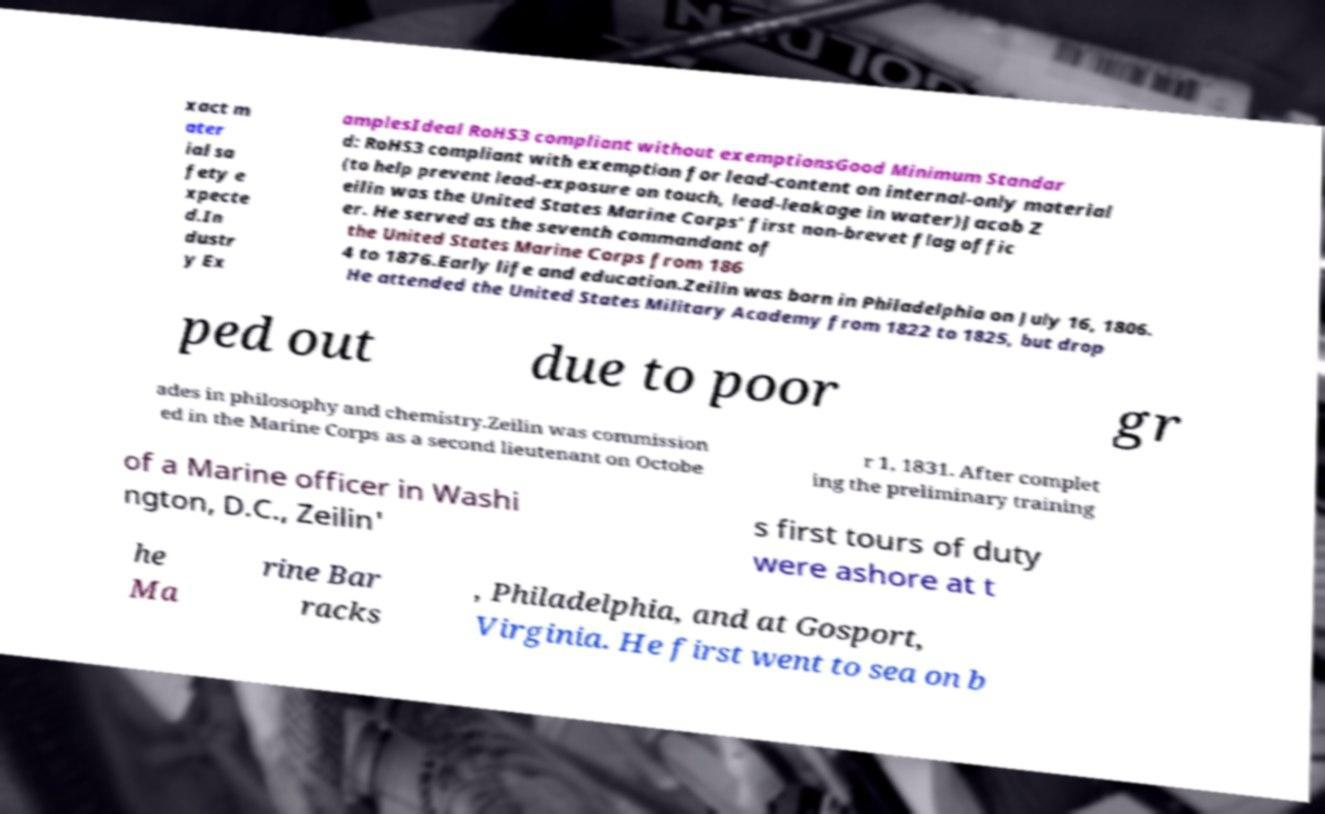There's text embedded in this image that I need extracted. Can you transcribe it verbatim? xact m ater ial sa fety e xpecte d.In dustr y Ex amplesIdeal RoHS3 compliant without exemptionsGood Minimum Standar d: RoHS3 compliant with exemption for lead-content on internal-only material (to help prevent lead-exposure on touch, lead-leakage in water)Jacob Z eilin was the United States Marine Corps' first non-brevet flag offic er. He served as the seventh commandant of the United States Marine Corps from 186 4 to 1876.Early life and education.Zeilin was born in Philadelphia on July 16, 1806. He attended the United States Military Academy from 1822 to 1825, but drop ped out due to poor gr ades in philosophy and chemistry.Zeilin was commission ed in the Marine Corps as a second lieutenant on Octobe r 1, 1831. After complet ing the preliminary training of a Marine officer in Washi ngton, D.C., Zeilin' s first tours of duty were ashore at t he Ma rine Bar racks , Philadelphia, and at Gosport, Virginia. He first went to sea on b 